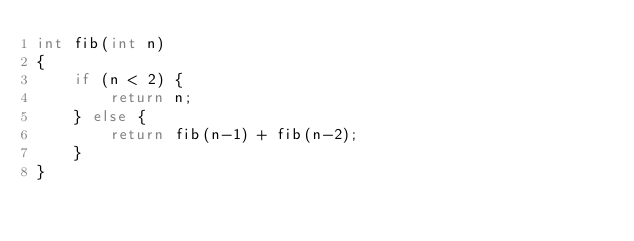<code> <loc_0><loc_0><loc_500><loc_500><_C_>int fib(int n)
{
    if (n < 2) {
        return n;
    } else {
        return fib(n-1) + fib(n-2);
    }
}
</code> 